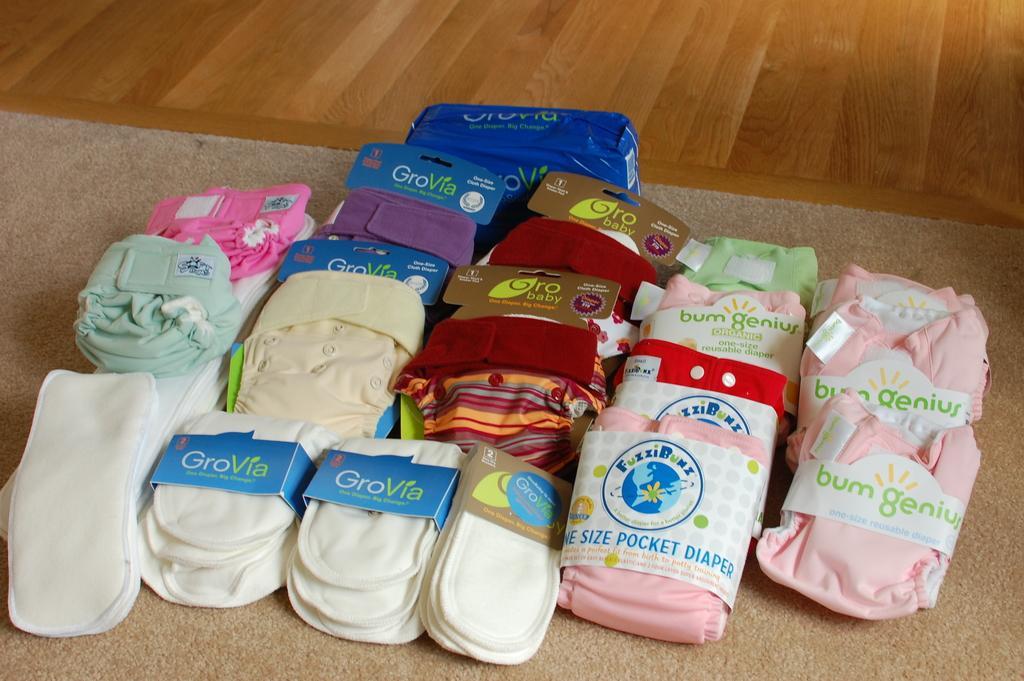How would you summarize this image in a sentence or two? This picture consists of diapers in the center of the image on a rug. 